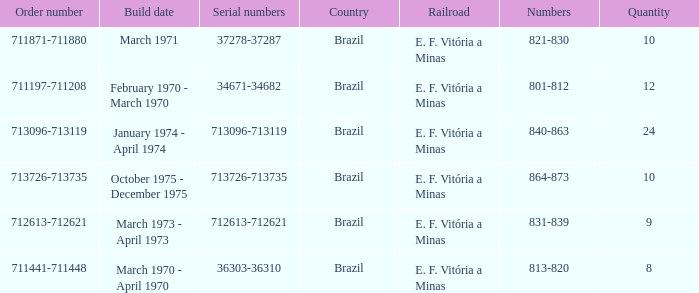How many railroads have the numbers 864-873? 1.0. I'm looking to parse the entire table for insights. Could you assist me with that? {'header': ['Order number', 'Build date', 'Serial numbers', 'Country', 'Railroad', 'Numbers', 'Quantity'], 'rows': [['711871-711880', 'March 1971', '37278-37287', 'Brazil', 'E. F. Vitória a Minas', '821-830', '10'], ['711197-711208', 'February 1970 - March 1970', '34671-34682', 'Brazil', 'E. F. Vitória a Minas', '801-812', '12'], ['713096-713119', 'January 1974 - April 1974', '713096-713119', 'Brazil', 'E. F. Vitória a Minas', '840-863', '24'], ['713726-713735', 'October 1975 - December 1975', '713726-713735', 'Brazil', 'E. F. Vitória a Minas', '864-873', '10'], ['712613-712621', 'March 1973 - April 1973', '712613-712621', 'Brazil', 'E. F. Vitória a Minas', '831-839', '9'], ['711441-711448', 'March 1970 - April 1970', '36303-36310', 'Brazil', 'E. F. Vitória a Minas', '813-820', '8']]} 